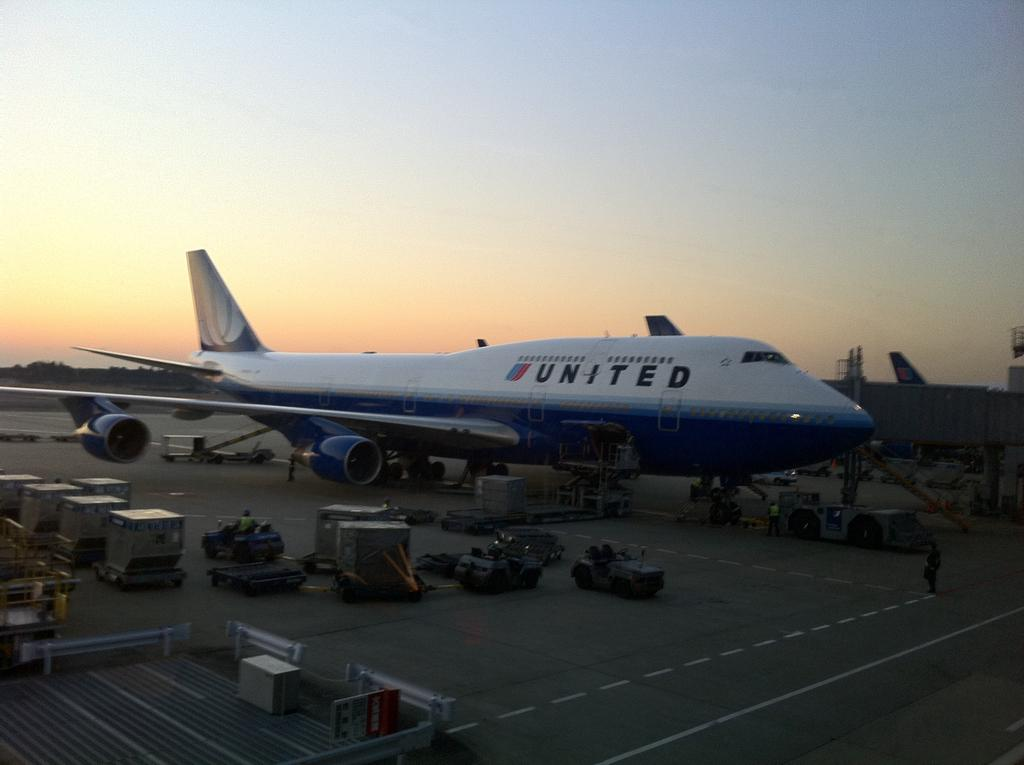<image>
Create a compact narrative representing the image presented. A United flight at the terminal at dusk or sunrise 